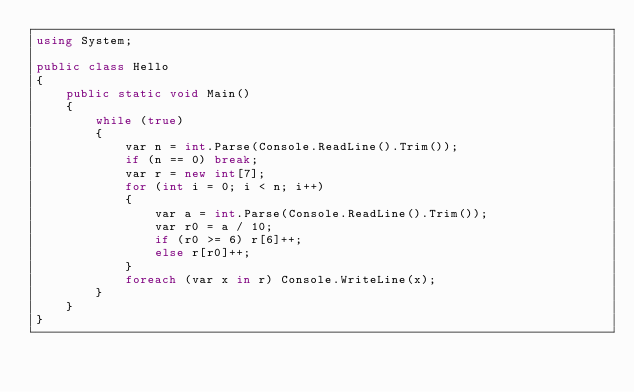<code> <loc_0><loc_0><loc_500><loc_500><_C#_>using System;

public class Hello
{
    public static void Main()
    {
        while (true)
        {
            var n = int.Parse(Console.ReadLine().Trim());
            if (n == 0) break;
            var r = new int[7];
            for (int i = 0; i < n; i++)
            {
                var a = int.Parse(Console.ReadLine().Trim());
                var r0 = a / 10;
                if (r0 >= 6) r[6]++;
                else r[r0]++;
            }
            foreach (var x in r) Console.WriteLine(x);
        }
    }
}</code> 